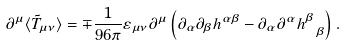Convert formula to latex. <formula><loc_0><loc_0><loc_500><loc_500>\partial ^ { \mu } \langle \tilde { T } _ { \mu \nu } \rangle = \mp \frac { 1 } { 9 6 \pi } \varepsilon _ { \mu \nu } \partial ^ { \mu } \left ( \partial _ { \alpha } \partial _ { \beta } h ^ { \alpha \beta } - \partial _ { \alpha } \partial ^ { \alpha } h ^ { \beta } _ { \ \beta } \right ) .</formula> 